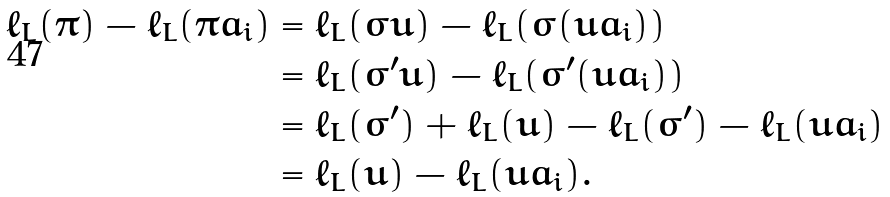<formula> <loc_0><loc_0><loc_500><loc_500>\ell _ { L } ( \pi ) - \ell _ { L } ( \pi a _ { i } ) & = \ell _ { L } ( \sigma u ) - \ell _ { L } ( \sigma ( u a _ { i } ) ) \\ & = \ell _ { L } ( \sigma ^ { \prime } u ) - \ell _ { L } ( \sigma ^ { \prime } ( u a _ { i } ) ) \\ & = \ell _ { L } ( \sigma ^ { \prime } ) + \ell _ { L } ( u ) - \ell _ { L } ( \sigma ^ { \prime } ) - \ell _ { L } ( u a _ { i } ) \\ & = \ell _ { L } ( u ) - \ell _ { L } ( u a _ { i } ) .</formula> 